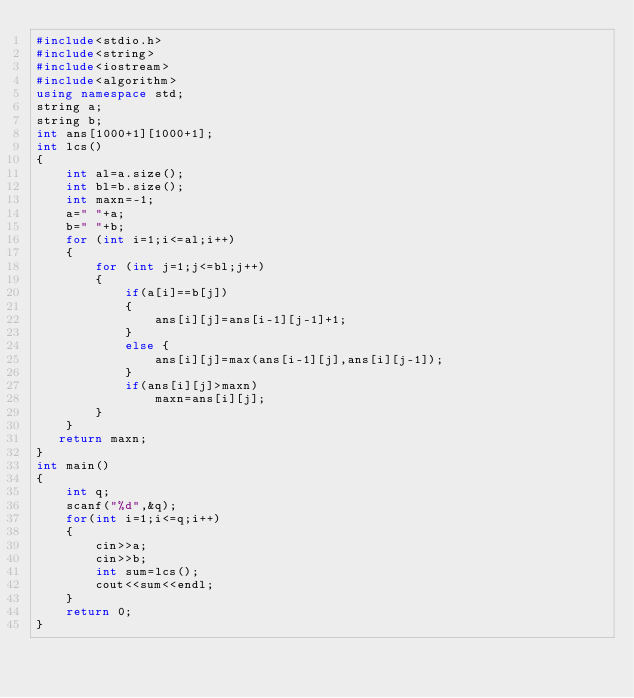Convert code to text. <code><loc_0><loc_0><loc_500><loc_500><_C++_>#include<stdio.h>
#include<string>
#include<iostream>
#include<algorithm>
using namespace std;
string a;
string b;
int ans[1000+1][1000+1];
int lcs()
{
    int al=a.size();
    int bl=b.size();
    int maxn=-1;
    a=" "+a;
    b=" "+b;
    for (int i=1;i<=al;i++)
    {
        for (int j=1;j<=bl;j++)
        {
            if(a[i]==b[j])
            {
                ans[i][j]=ans[i-1][j-1]+1;
            }
            else {
                ans[i][j]=max(ans[i-1][j],ans[i][j-1]);
            }
            if(ans[i][j]>maxn)
                maxn=ans[i][j];
        }
    }
   return maxn;
}
int main()
{
    int q;
    scanf("%d",&q);
    for(int i=1;i<=q;i++)
    {
        cin>>a;
        cin>>b;
        int sum=lcs();
        cout<<sum<<endl;
    }
    return 0;
}</code> 